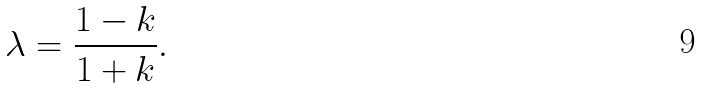<formula> <loc_0><loc_0><loc_500><loc_500>\lambda = \frac { 1 - k } { 1 + k } .</formula> 